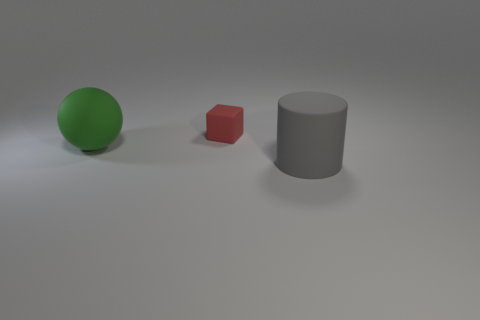What size is the gray cylinder?
Provide a succinct answer. Large. What number of other objects are the same size as the gray thing?
Your answer should be compact. 1. What number of other green rubber things are the same shape as the small thing?
Provide a succinct answer. 0. Is the number of large cylinders to the right of the big gray matte object the same as the number of tiny cyan cylinders?
Offer a terse response. Yes. Is there anything else that is the same size as the green thing?
Your answer should be very brief. Yes. There is another thing that is the same size as the gray rubber object; what is its shape?
Ensure brevity in your answer.  Sphere. Is there another small thing of the same shape as the green rubber thing?
Ensure brevity in your answer.  No. There is a large thing on the right side of the large thing that is left of the rubber block; are there any big green things that are in front of it?
Your response must be concise. No. Are there more rubber balls behind the small cube than green spheres that are in front of the gray rubber object?
Keep it short and to the point. No. There is a green ball that is the same size as the gray rubber cylinder; what is it made of?
Your answer should be very brief. Rubber. 